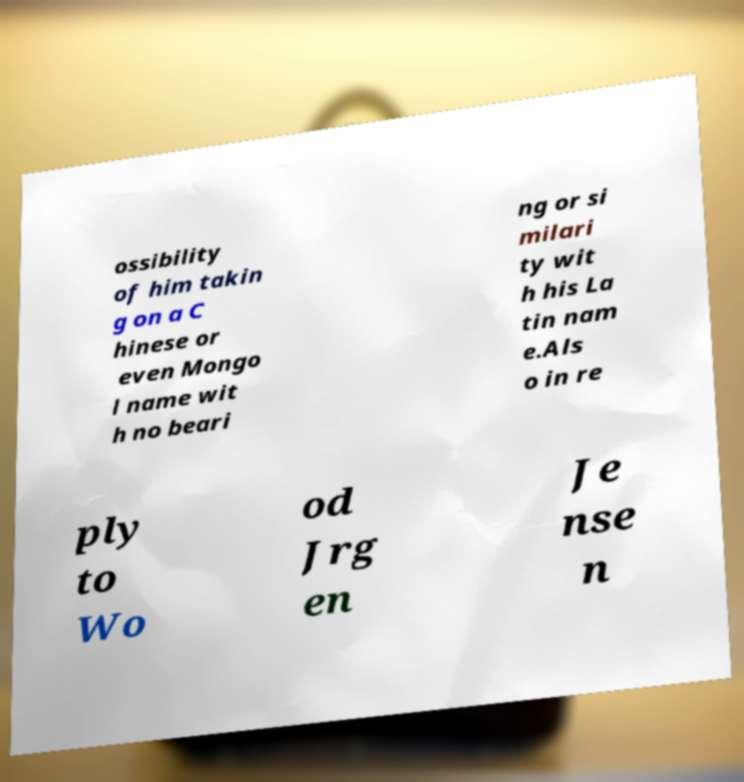Please identify and transcribe the text found in this image. ossibility of him takin g on a C hinese or even Mongo l name wit h no beari ng or si milari ty wit h his La tin nam e.Als o in re ply to Wo od Jrg en Je nse n 